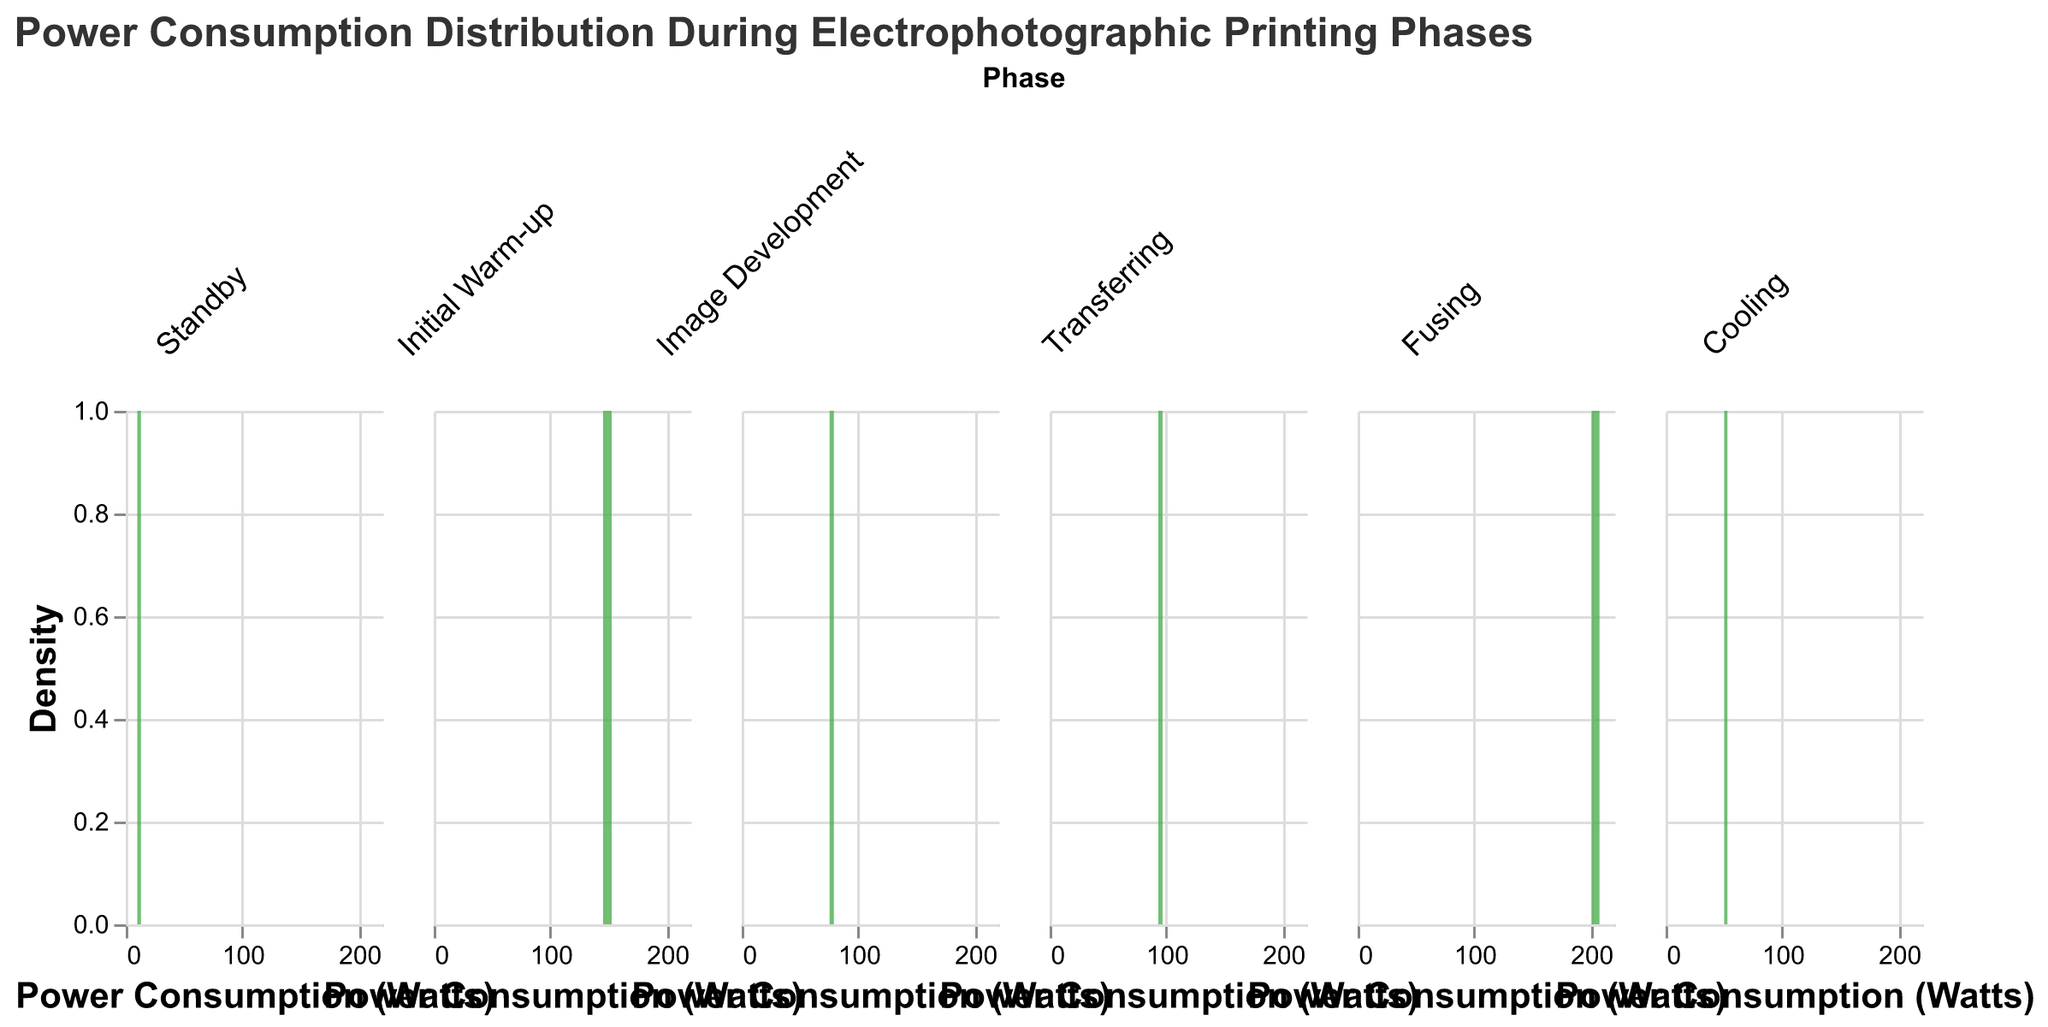What is the average power consumption during the 'Standby' phase? Sum the power consumption values during the 'Standby' phase, which are 10.5, 12.3, 11.8, 13.1, and 9.9. The total sum is 57.6. Divide this by the number of evaluations (5). Therefore, the average power consumption is 57.6 / 5.
Answer: 11.52 Which phase has the highest maximum power consumption? Compare the highest power consumption values across all phases: Standby (13.1), Initial Warm-up (152.5), Image Development (79.0), Transferring (96.8), Fusing (207.4), and Cooling (53.0). The highest value is 207.4 in the Fusing phase.
Answer: Fusing Which phase has the lowest mean power consumption? Calculate and compare the average power consumption for each phase. Standby (11.52), Initial Warm-up (148.64), Image Development (77.34), Transferring (94.94), Fusing (204.12), Cooling (51.46). The lowest mean power consumption is 11.52 in the Standby phase.
Answer: Standby During which phase is the power consumption distribution the widest? Identify the difference between the highest and lowest power consumption for each phase: Standby (13.1 - 9.9 = 3.2), Initial Warm-up (152.5 - 145.2 = 7.3), Image Development (79.0 - 75.3 = 3.7), Transferring (96.8 - 93.1 = 3.7), Fusing (207.4 - 200.5 = 6.9), Cooling (53.0 - 50.3 = 2.7). The widest distribution is in the Initial Warm-up phase with a range of 7.3.
Answer: Initial Warm-up How does the power consumption in the 'Cool down' phase compare to the 'Standby' phase? Look at the average power consumption for the Cooling (51.46) and Standby (11.52). The Cooling phase has a significantly higher average power consumption compared to the Standby phase.
Answer: Cooling phase has higher power consumption Which phase has the narrowest range of power consumption values? Calculate the range of power consumption values for each phase: Standby (3.2), Initial Warm-up (7.3), Image Development (3.7), Transferring (3.7), Fusing (6.9), Cooling (2.7). The narrowest range is in the Cooling phase with a difference of 2.7.
Answer: Cooling What is a notable feature of the power consumption distribution during the 'Fusing' phase? The figure shows that the 'Fusing' phase has the highest power consumption values and the widest distribution, indicating it is the most energy-intensive and variable phase.
Answer: High and variable What is the difference between the maximum power consumption during 'Initial Warm-up' and 'Image Development'? The maximum power consumption for 'Initial Warm-up' is 152.5, and for 'Image Development' is 79.0. The difference is 152.5 - 79.0 = 73.5.
Answer: 73.5 How consistent is the power consumption during the 'Transferring' phase? The power consumption values for 'Transferring' phase are relatively close in range (93.1 to 96.8), showing a narrow distribution and indicating consistency.
Answer: Consistent Does the power consumption during 'Cooling' phase surpass 'Image Development'? Compare the average power consumption of Cooling (51.46) with Image Development (77.34). The Cooling phase has a lower average power consumption compared to Image Development.
Answer: No 